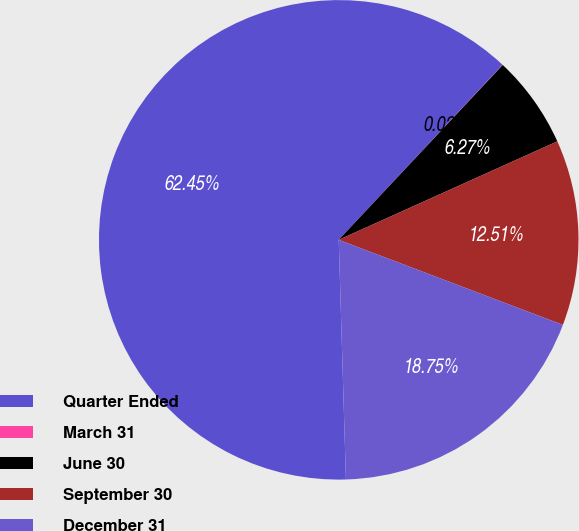<chart> <loc_0><loc_0><loc_500><loc_500><pie_chart><fcel>Quarter Ended<fcel>March 31<fcel>June 30<fcel>September 30<fcel>December 31<nl><fcel>62.45%<fcel>0.02%<fcel>6.27%<fcel>12.51%<fcel>18.75%<nl></chart> 